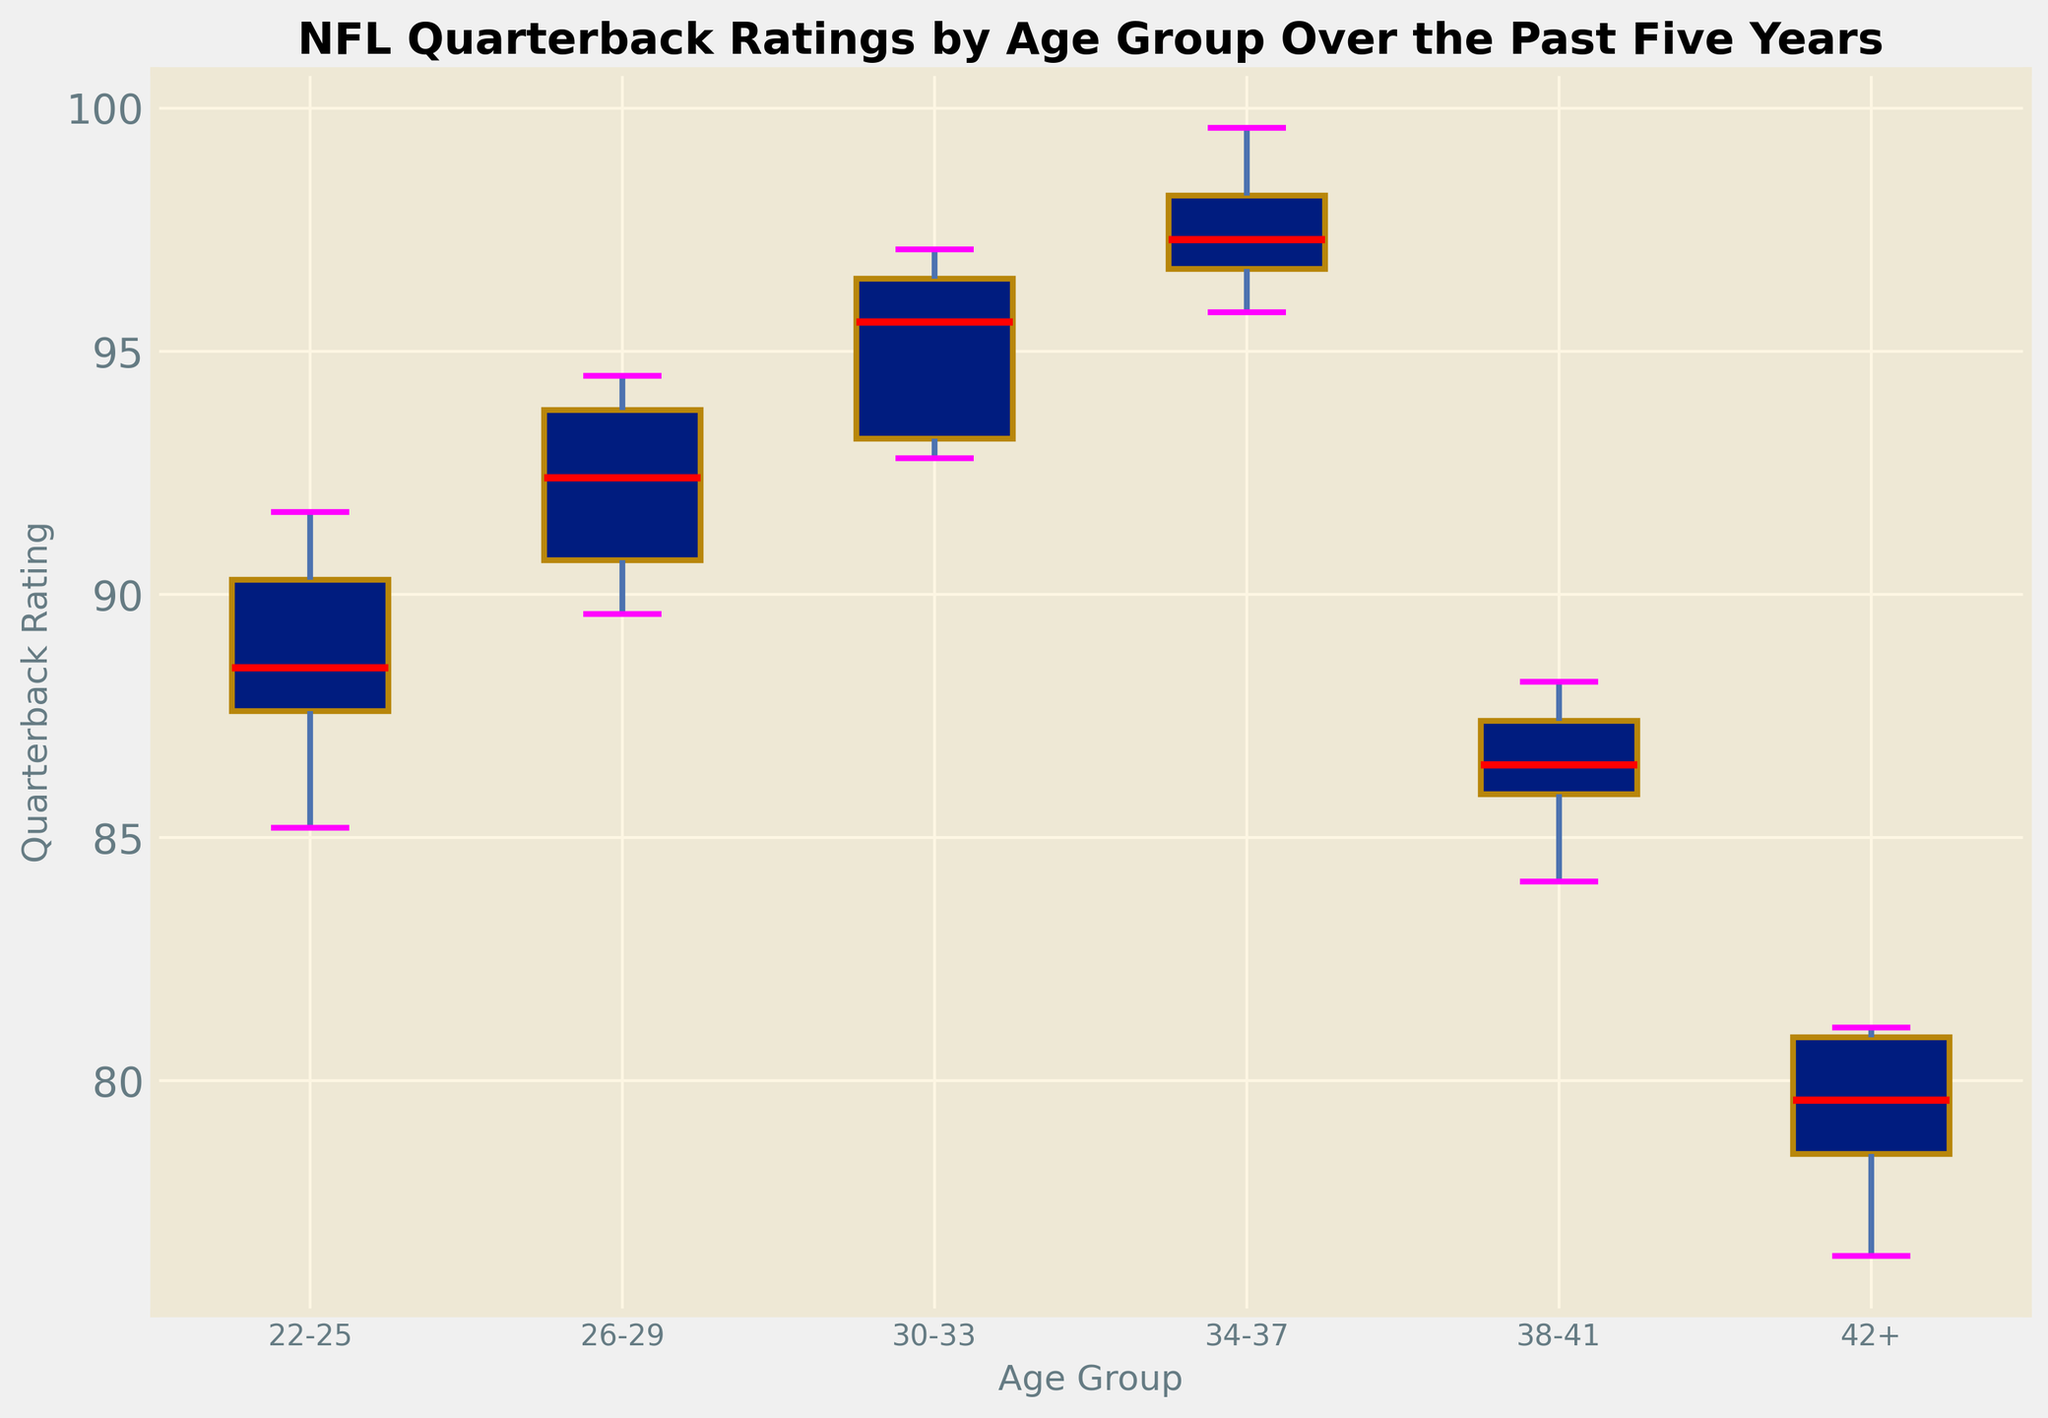Which age group has the highest median quarterback rating? Look for the median line (in red) in each boxplot, and identify the age group with the highest median line.
Answer: 34-37 What is the range of quarterback ratings for the 22-25 age group? In the boxplot, the range is the difference between the highest whisker and the lowest whisker in the 22-25 age group.
Answer: 85.2 to 91.7 Which age group shows the most variability in quarterback ratings based on the interquartile range (IQR)? The IQR is represented by the length of the box. Identify the age group with the longest box.
Answer: 22-25 How does the median quarterback rating change as players get older? Observe the median lines (in red) in each boxplot and note the pattern as the age groups progress from youngest to oldest.
Answer: Initially increases, then decreases for 38-41 and 42+ Which age group has the lowest median quarterback rating? Identify the age group with the lowest median line (in red) in the boxplot.
Answer: 42+ How do the ratings of quarterbacks aged 30-33 compare to those aged 26-29? Compare the positions of the boxes, whiskers, and median lines of the 30-33 age group with the 26-29 age group.
Answer: 30-33 age group has higher ratings Which age group contains the highest individual quarterback rating? Look for the highest outlier or whisker in all the boxplots to identify the age group.
Answer: 34-37 What is the median rating for quarterbacks aged 34-37? Locate the red median line within the 34-37 age group's boxplot and read the value.
Answer: 97.3 Which age group's boxplot has the smallest width, suggesting the least variability? The box width represents variability among ratings. Identify the age group with the narrowest box.
Answer: 38-41 